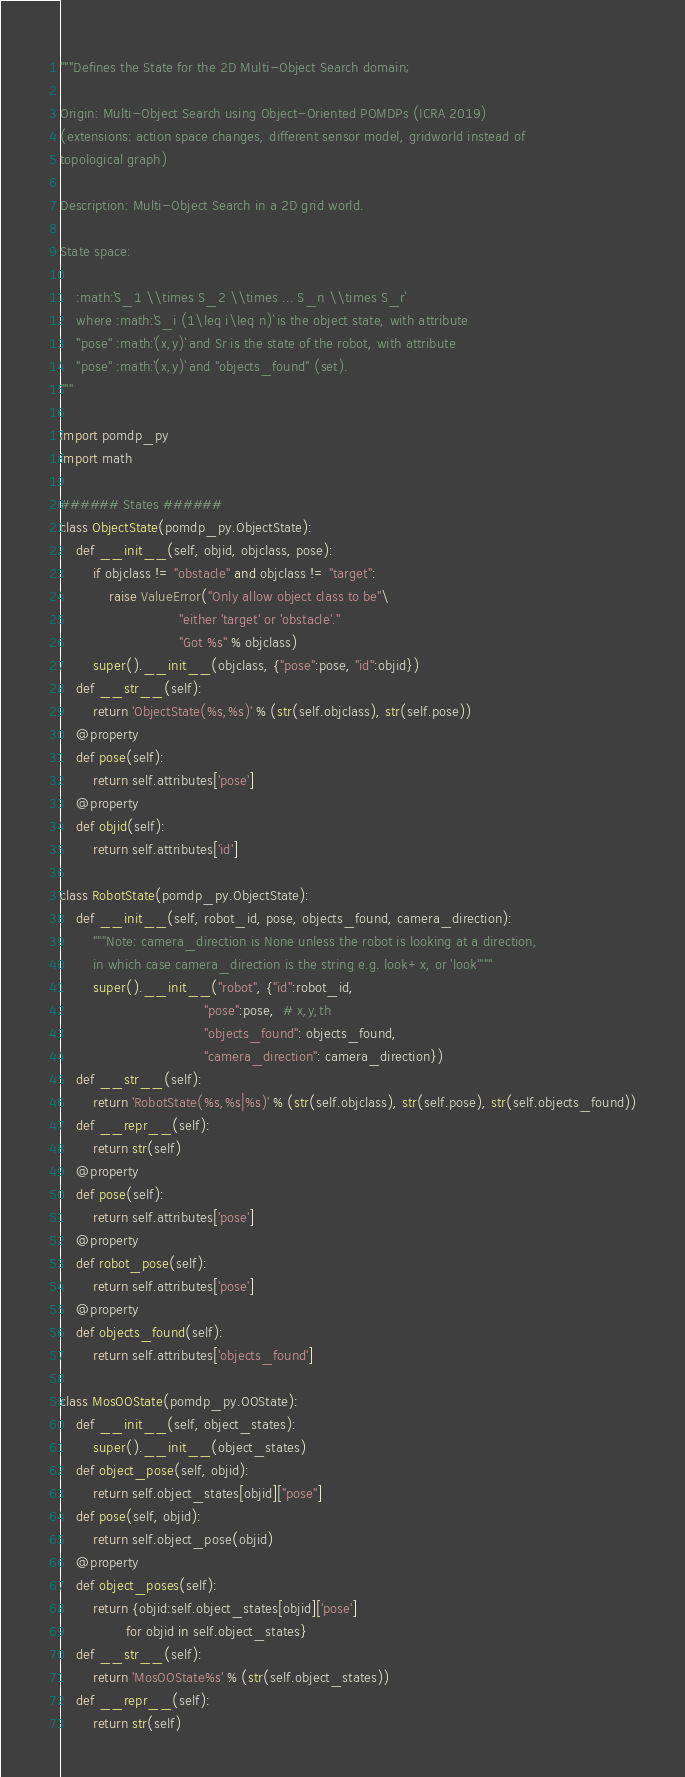<code> <loc_0><loc_0><loc_500><loc_500><_Python_>"""Defines the State for the 2D Multi-Object Search domain;

Origin: Multi-Object Search using Object-Oriented POMDPs (ICRA 2019)
(extensions: action space changes, different sensor model, gridworld instead of
topological graph)

Description: Multi-Object Search in a 2D grid world.

State space: 

    :math:`S_1 \\times S_2 \\times ... S_n \\times S_r`
    where :math:`S_i (1\leq i\leq n)` is the object state, with attribute
    "pose" :math:`(x,y)` and Sr is the state of the robot, with attribute
    "pose" :math:`(x,y)` and "objects_found" (set).
"""

import pomdp_py
import math

###### States ######
class ObjectState(pomdp_py.ObjectState):
    def __init__(self, objid, objclass, pose):
        if objclass != "obstacle" and objclass != "target":
            raise ValueError("Only allow object class to be"\
                             "either 'target' or 'obstacle'."
                             "Got %s" % objclass)
        super().__init__(objclass, {"pose":pose, "id":objid})
    def __str__(self):
        return 'ObjectState(%s,%s)' % (str(self.objclass), str(self.pose))
    @property
    def pose(self):
        return self.attributes['pose']
    @property
    def objid(self):
        return self.attributes['id']

class RobotState(pomdp_py.ObjectState):
    def __init__(self, robot_id, pose, objects_found, camera_direction):
        """Note: camera_direction is None unless the robot is looking at a direction,
        in which case camera_direction is the string e.g. look+x, or 'look'"""
        super().__init__("robot", {"id":robot_id,
                                   "pose":pose,  # x,y,th
                                   "objects_found": objects_found,
                                   "camera_direction": camera_direction})
    def __str__(self):
        return 'RobotState(%s,%s|%s)' % (str(self.objclass), str(self.pose), str(self.objects_found))
    def __repr__(self):
        return str(self)
    @property
    def pose(self):
        return self.attributes['pose']
    @property
    def robot_pose(self):
        return self.attributes['pose']
    @property
    def objects_found(self):
        return self.attributes['objects_found']

class MosOOState(pomdp_py.OOState):
    def __init__(self, object_states):
        super().__init__(object_states)
    def object_pose(self, objid):
        return self.object_states[objid]["pose"]
    def pose(self, objid):
        return self.object_pose(objid)
    @property
    def object_poses(self):
        return {objid:self.object_states[objid]['pose']
                for objid in self.object_states}
    def __str__(self):
        return 'MosOOState%s' % (str(self.object_states))
    def __repr__(self):
        return str(self)
</code> 